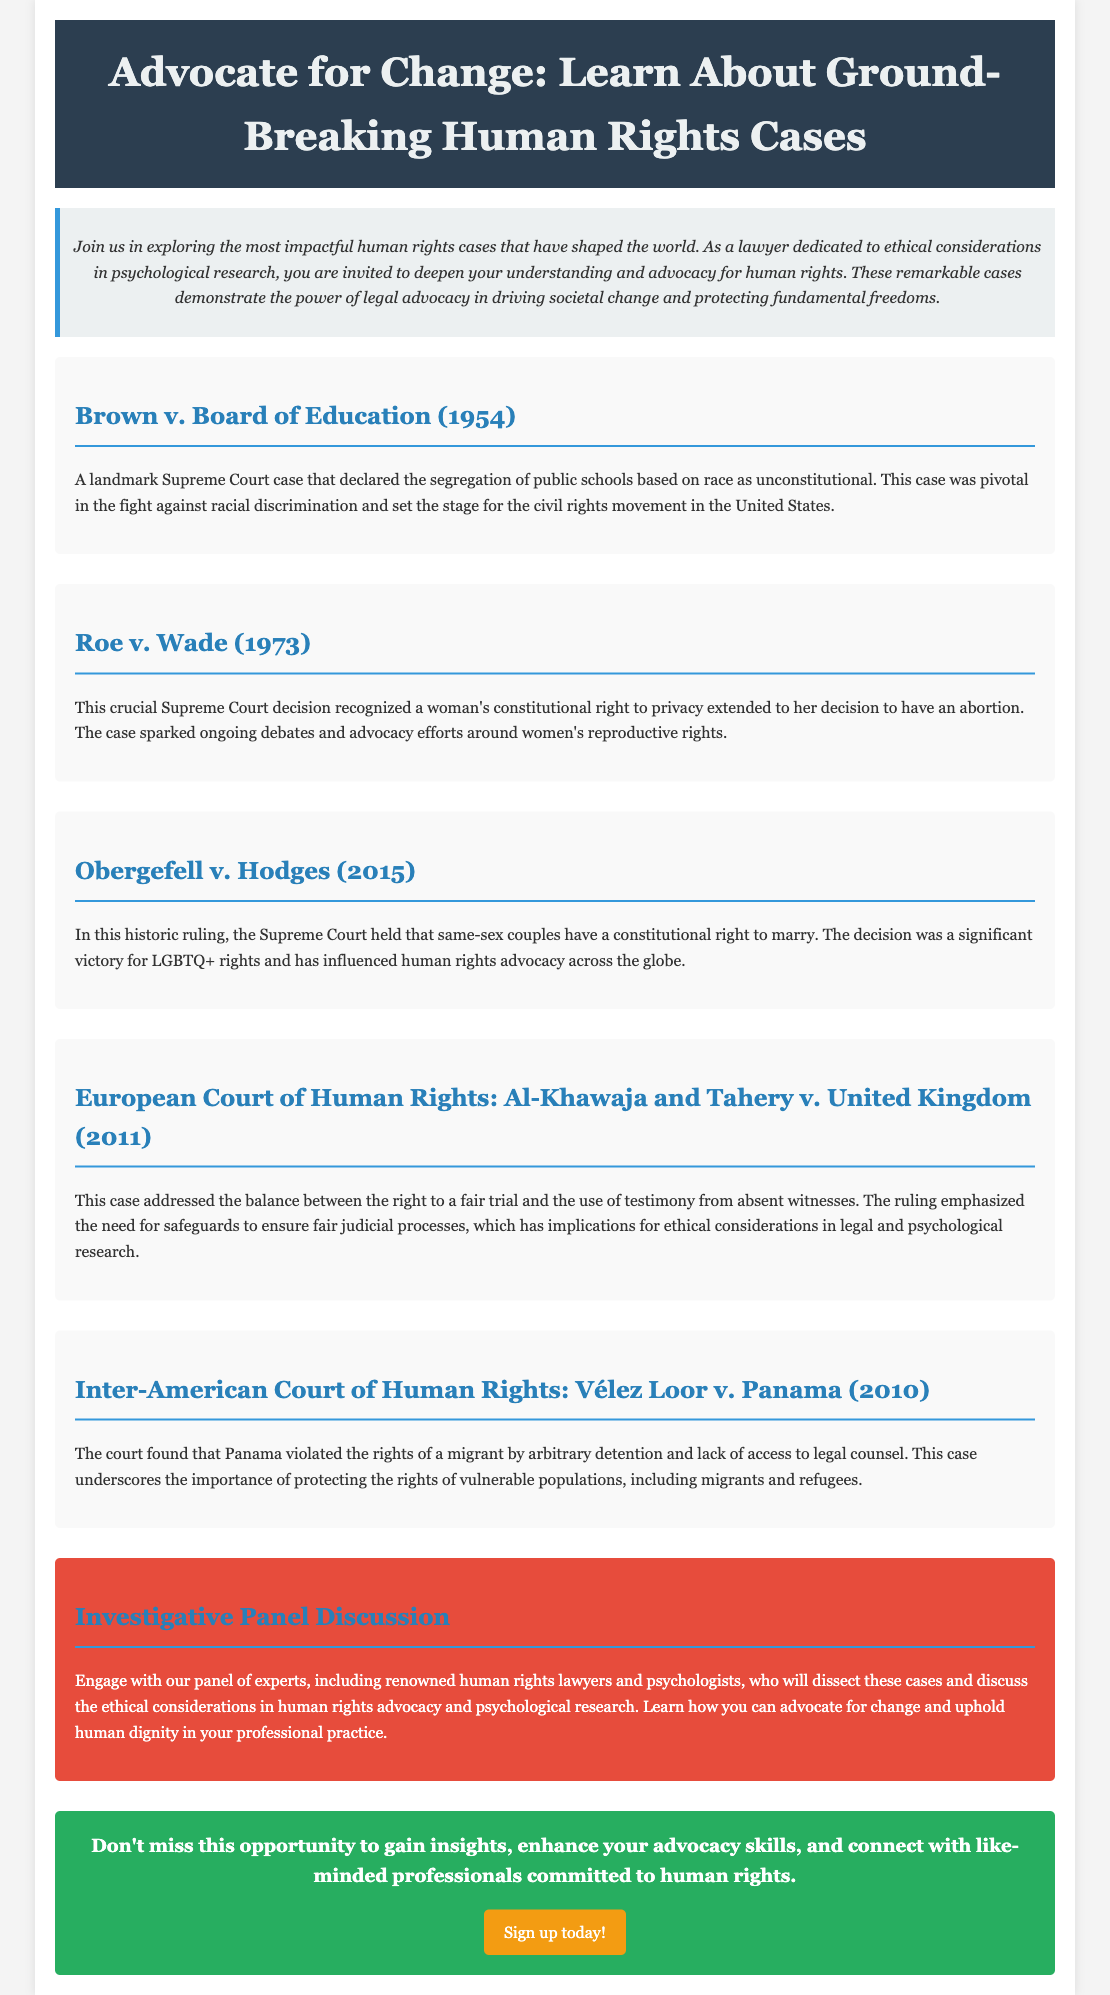What is the title of the advertisement? The title of the advertisement is displayed prominently at the top of the document, stating the focus on human rights cases.
Answer: Advocate for Change: Learn About Ground-Breaking Human Rights Cases What year was Brown v. Board of Education decided? The decision date is included with the case information to indicate its historical significance.
Answer: 1954 Which court decided Roe v. Wade? The court is specified in the description of the case, indicating its legal authority in this landmark decision.
Answer: Supreme Court What is the primary right recognized in Obergefell v. Hodges? The document outlines the focus of the case and its implications for civil rights.
Answer: Right to marry What key ethical issue does Al-Khawaja and Tahery v. United Kingdom address? The document notes the implications of the case regarding legal processes that relate to human rights.
Answer: Fair trial What type of professional is the panel discussion targeted at? The advertisement clearly specifies the audience for the panel discussion based on their professional background.
Answer: Experts in human rights What color is used for the background of the container? The color scheme is an important design aspect highlighted in the document.
Answer: White What opportunity is highlighted at the end of the advertisement? The document emphasizes a call to action regarding gaining insights and skills.
Answer: Sign up today! 